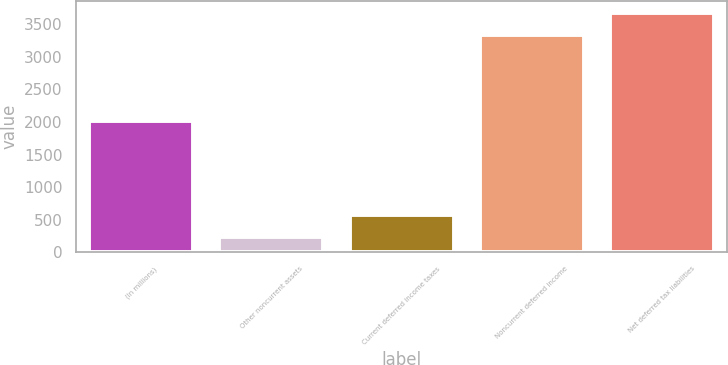Convert chart. <chart><loc_0><loc_0><loc_500><loc_500><bar_chart><fcel>(In millions)<fcel>Other noncurrent assets<fcel>Current deferred income taxes<fcel>Noncurrent deferred income<fcel>Net deferred tax liabilities<nl><fcel>2008<fcel>243<fcel>579.9<fcel>3330<fcel>3666.9<nl></chart> 